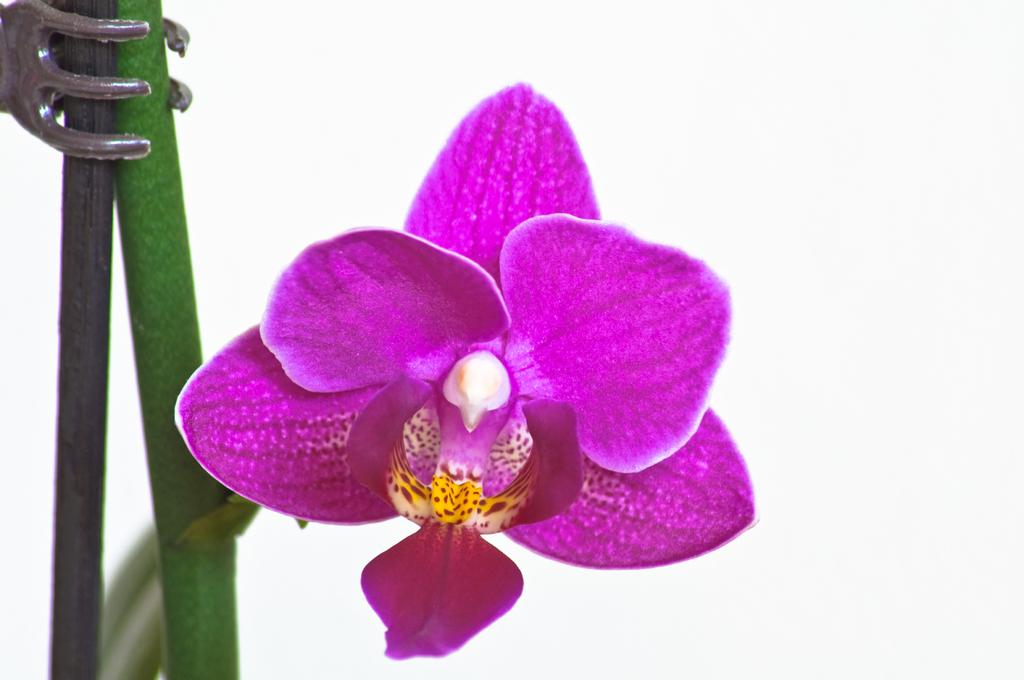What is the main subject of the image? The main subject of the image is a flower. Can you describe the flower's structure? The flower has a stem. What color is the flower? The flower is purple in color. What type of watch is the horse wearing in the image? There is no watch or horse present in the image; it features a purple flower with a stem. 